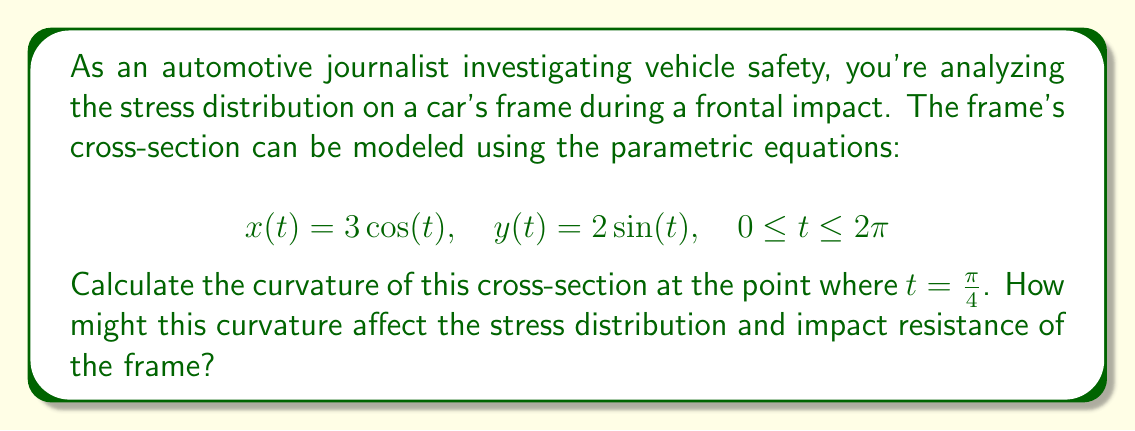Solve this math problem. To solve this problem, we'll follow these steps:

1) The curvature $\kappa$ of a curve given by parametric equations is:

   $$\kappa = \frac{|x'y'' - y'x''|}{(x'^2 + y'^2)^{3/2}}$$

2) We need to find $x'(t)$, $y'(t)$, $x''(t)$, and $y''(t)$:
   
   $$x'(t) = -3\sin(t)$$
   $$y'(t) = 2\cos(t)$$
   $$x''(t) = -3\cos(t)$$
   $$y''(t) = -2\sin(t)$$

3) Now, let's substitute $t = \frac{\pi}{4}$ into these expressions:
   
   $$x'(\frac{\pi}{4}) = -3\sin(\frac{\pi}{4}) = -\frac{3\sqrt{2}}{2}$$
   $$y'(\frac{\pi}{4}) = 2\cos(\frac{\pi}{4}) = \sqrt{2}$$
   $$x''(\frac{\pi}{4}) = -3\cos(\frac{\pi}{4}) = -\frac{3\sqrt{2}}{2}$$
   $$y''(\frac{\pi}{4}) = -2\sin(\frac{\pi}{4}) = -\sqrt{2}$$

4) Substituting these values into the curvature formula:

   $$\kappa = \frac{|-\frac{3\sqrt{2}}{2}(-\sqrt{2}) - \sqrt{2}(-\frac{3\sqrt{2}}{2})|}{((-\frac{3\sqrt{2}}{2})^2 + (\sqrt{2})^2)^{3/2}}$$

5) Simplifying:

   $$\kappa = \frac{3 + 3}{((\frac{9}{2} + 2))^{3/2}} = \frac{6}{(\frac{13}{2})^{3/2}} = \frac{6}{(\frac{13}{2})^{3/2}} \cdot \frac{2^{3/2}}{2^{3/2}} = \frac{12\sqrt{2}}{13\sqrt{13}}$$

The curvature at this point affects the stress distribution and impact resistance. A higher curvature generally implies a more abrupt change in direction, which can lead to stress concentration. However, some curvature is beneficial for distributing impact forces. The specific value calculated here would need to be compared to industry standards and other parts of the frame to fully assess its impact on vehicle safety.
Answer: The curvature of the car frame's cross-section at $t = \frac{\pi}{4}$ is $\frac{12\sqrt{2}}{13\sqrt{13}}$. 